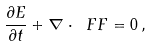Convert formula to latex. <formula><loc_0><loc_0><loc_500><loc_500>\frac { \partial E } { \partial t } + \nabla \cdot \ F F = 0 \, , \\</formula> 